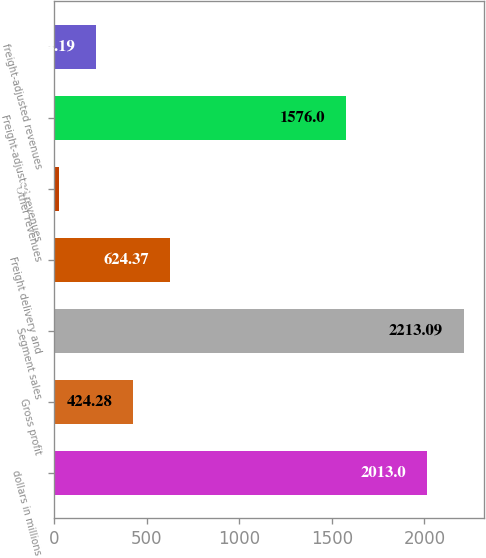Convert chart. <chart><loc_0><loc_0><loc_500><loc_500><bar_chart><fcel>dollars in millions<fcel>Gross profit<fcel>Segment sales<fcel>Freight delivery and<fcel>Other revenues<fcel>Freight-adjusted revenues<fcel>freight-adjusted revenues<nl><fcel>2013<fcel>424.28<fcel>2213.09<fcel>624.37<fcel>24.1<fcel>1576<fcel>224.19<nl></chart> 